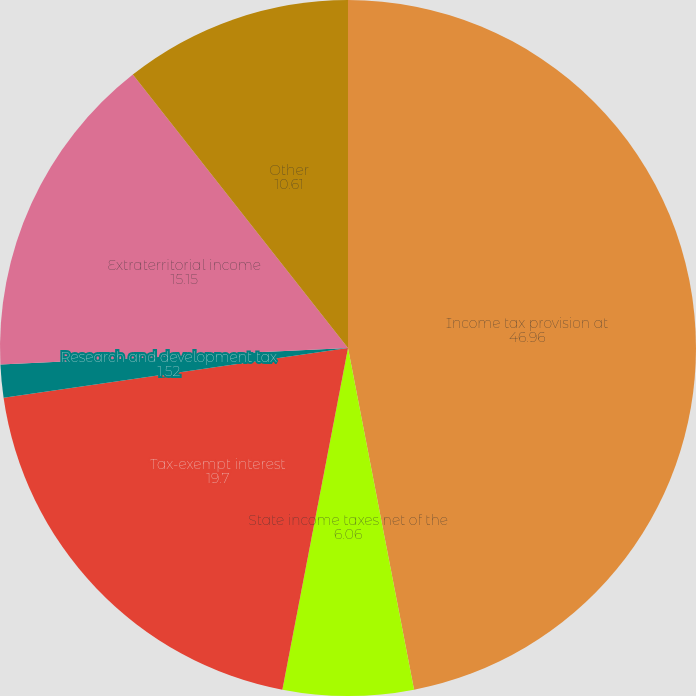Convert chart. <chart><loc_0><loc_0><loc_500><loc_500><pie_chart><fcel>Income tax provision at<fcel>State income taxes net of the<fcel>Tax-exempt interest<fcel>Research and development tax<fcel>Extraterritorial income<fcel>Other<nl><fcel>46.96%<fcel>6.06%<fcel>19.7%<fcel>1.52%<fcel>15.15%<fcel>10.61%<nl></chart> 